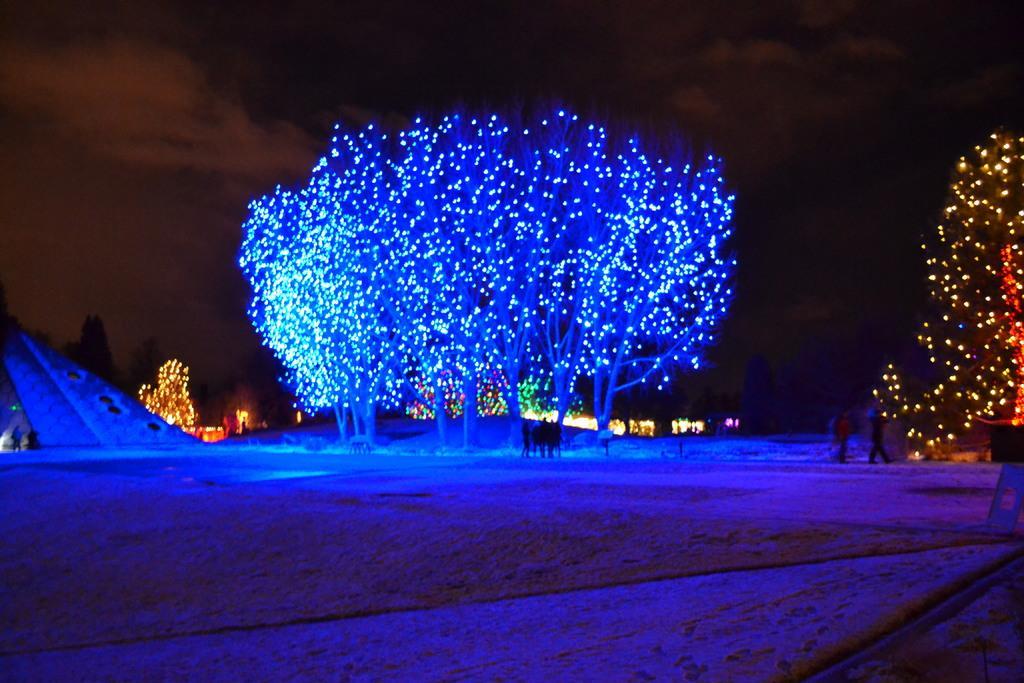Please provide a concise description of this image. In this image we can see sky with clouds, decor lights, trees and persons standing on the ground. 